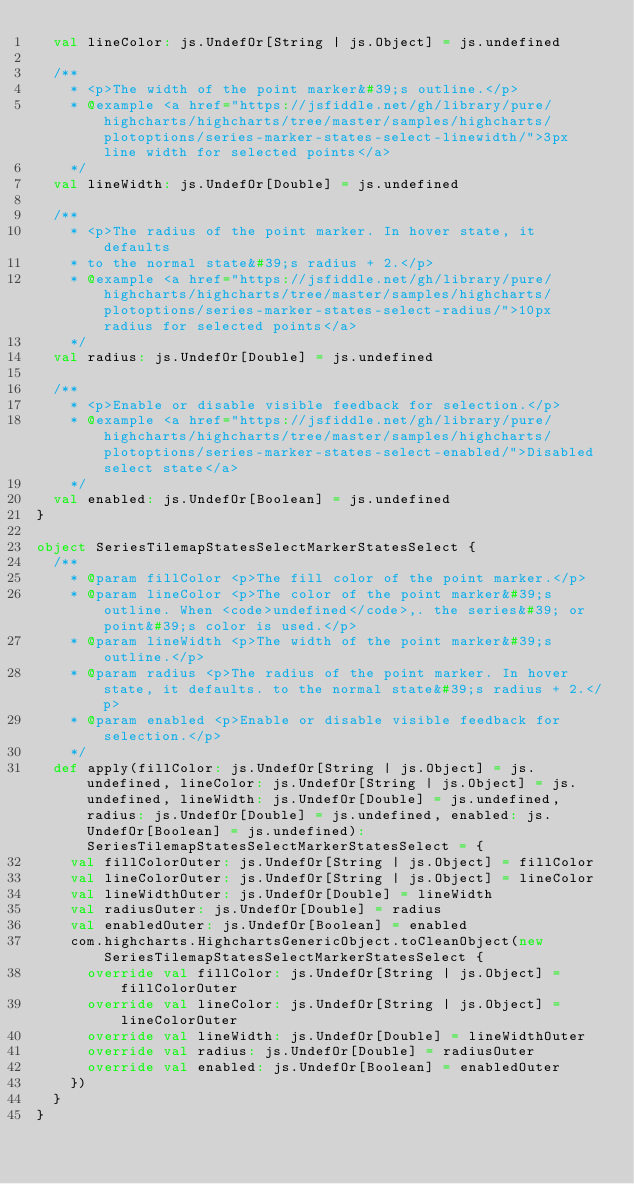<code> <loc_0><loc_0><loc_500><loc_500><_Scala_>  val lineColor: js.UndefOr[String | js.Object] = js.undefined

  /**
    * <p>The width of the point marker&#39;s outline.</p>
    * @example <a href="https://jsfiddle.net/gh/library/pure/highcharts/highcharts/tree/master/samples/highcharts/plotoptions/series-marker-states-select-linewidth/">3px line width for selected points</a>
    */
  val lineWidth: js.UndefOr[Double] = js.undefined

  /**
    * <p>The radius of the point marker. In hover state, it defaults
    * to the normal state&#39;s radius + 2.</p>
    * @example <a href="https://jsfiddle.net/gh/library/pure/highcharts/highcharts/tree/master/samples/highcharts/plotoptions/series-marker-states-select-radius/">10px radius for selected points</a>
    */
  val radius: js.UndefOr[Double] = js.undefined

  /**
    * <p>Enable or disable visible feedback for selection.</p>
    * @example <a href="https://jsfiddle.net/gh/library/pure/highcharts/highcharts/tree/master/samples/highcharts/plotoptions/series-marker-states-select-enabled/">Disabled select state</a>
    */
  val enabled: js.UndefOr[Boolean] = js.undefined
}

object SeriesTilemapStatesSelectMarkerStatesSelect {
  /**
    * @param fillColor <p>The fill color of the point marker.</p>
    * @param lineColor <p>The color of the point marker&#39;s outline. When <code>undefined</code>,. the series&#39; or point&#39;s color is used.</p>
    * @param lineWidth <p>The width of the point marker&#39;s outline.</p>
    * @param radius <p>The radius of the point marker. In hover state, it defaults. to the normal state&#39;s radius + 2.</p>
    * @param enabled <p>Enable or disable visible feedback for selection.</p>
    */
  def apply(fillColor: js.UndefOr[String | js.Object] = js.undefined, lineColor: js.UndefOr[String | js.Object] = js.undefined, lineWidth: js.UndefOr[Double] = js.undefined, radius: js.UndefOr[Double] = js.undefined, enabled: js.UndefOr[Boolean] = js.undefined): SeriesTilemapStatesSelectMarkerStatesSelect = {
    val fillColorOuter: js.UndefOr[String | js.Object] = fillColor
    val lineColorOuter: js.UndefOr[String | js.Object] = lineColor
    val lineWidthOuter: js.UndefOr[Double] = lineWidth
    val radiusOuter: js.UndefOr[Double] = radius
    val enabledOuter: js.UndefOr[Boolean] = enabled
    com.highcharts.HighchartsGenericObject.toCleanObject(new SeriesTilemapStatesSelectMarkerStatesSelect {
      override val fillColor: js.UndefOr[String | js.Object] = fillColorOuter
      override val lineColor: js.UndefOr[String | js.Object] = lineColorOuter
      override val lineWidth: js.UndefOr[Double] = lineWidthOuter
      override val radius: js.UndefOr[Double] = radiusOuter
      override val enabled: js.UndefOr[Boolean] = enabledOuter
    })
  }
}
</code> 